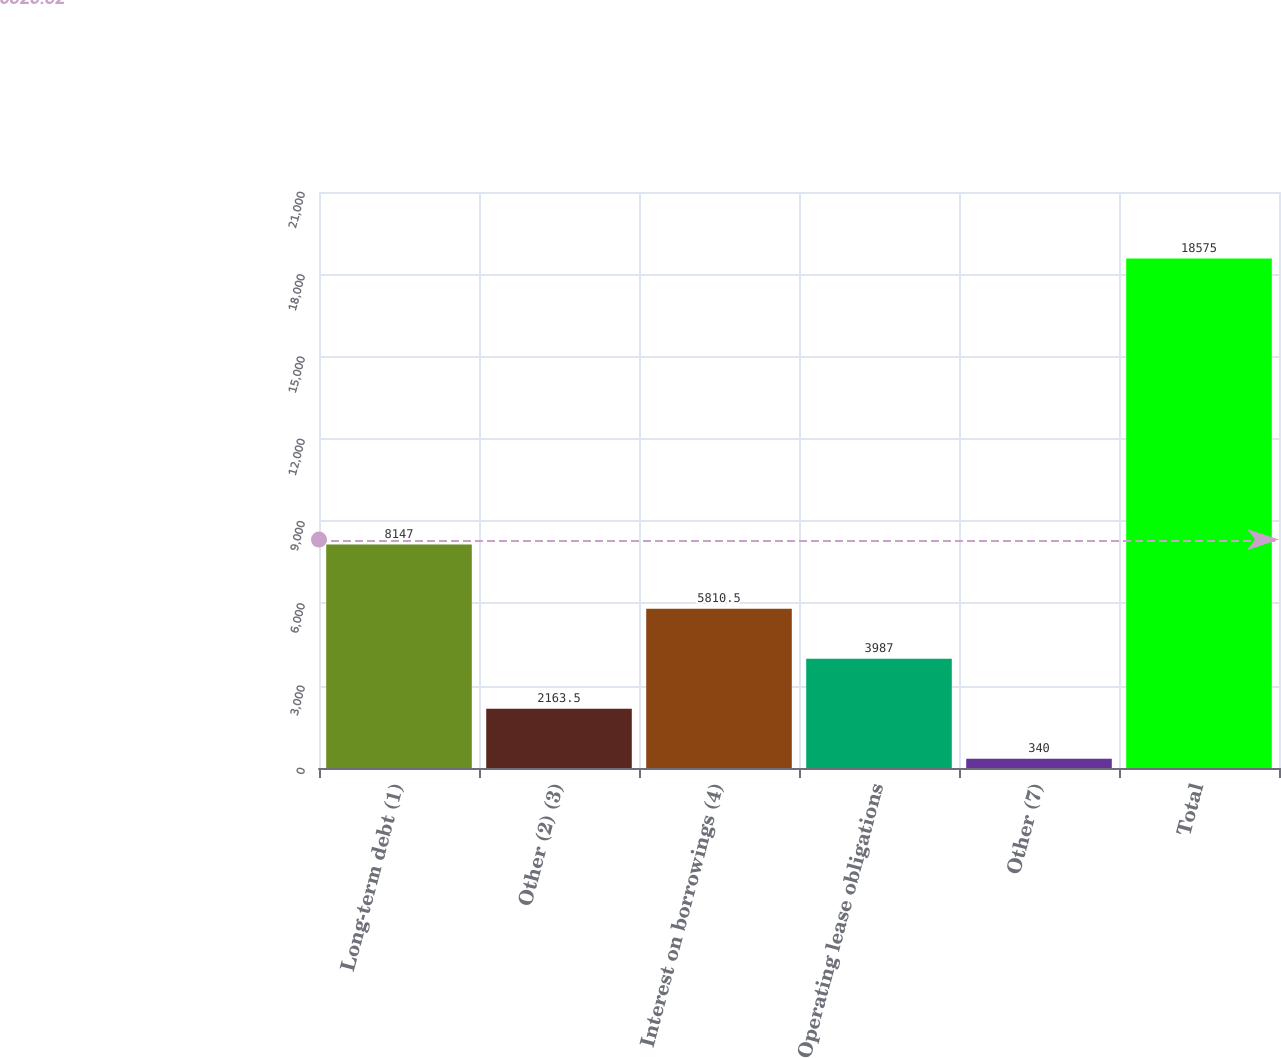Convert chart. <chart><loc_0><loc_0><loc_500><loc_500><bar_chart><fcel>Long-term debt (1)<fcel>Other (2) (3)<fcel>Interest on borrowings (4)<fcel>Operating lease obligations<fcel>Other (7)<fcel>Total<nl><fcel>8147<fcel>2163.5<fcel>5810.5<fcel>3987<fcel>340<fcel>18575<nl></chart> 